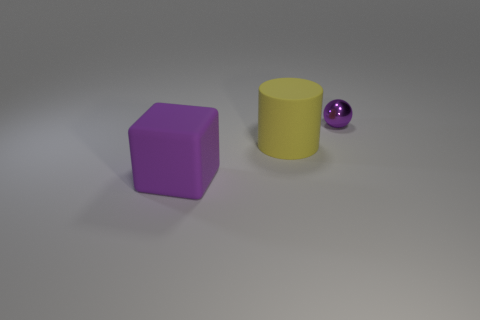Add 2 small purple cylinders. How many objects exist? 5 Subtract 0 cyan cylinders. How many objects are left? 3 Subtract all cubes. How many objects are left? 2 Subtract all yellow spheres. Subtract all brown blocks. How many spheres are left? 1 Subtract all gray cylinders. How many gray cubes are left? 0 Subtract all tiny green metal spheres. Subtract all metallic objects. How many objects are left? 2 Add 3 purple cubes. How many purple cubes are left? 4 Add 1 yellow rubber objects. How many yellow rubber objects exist? 2 